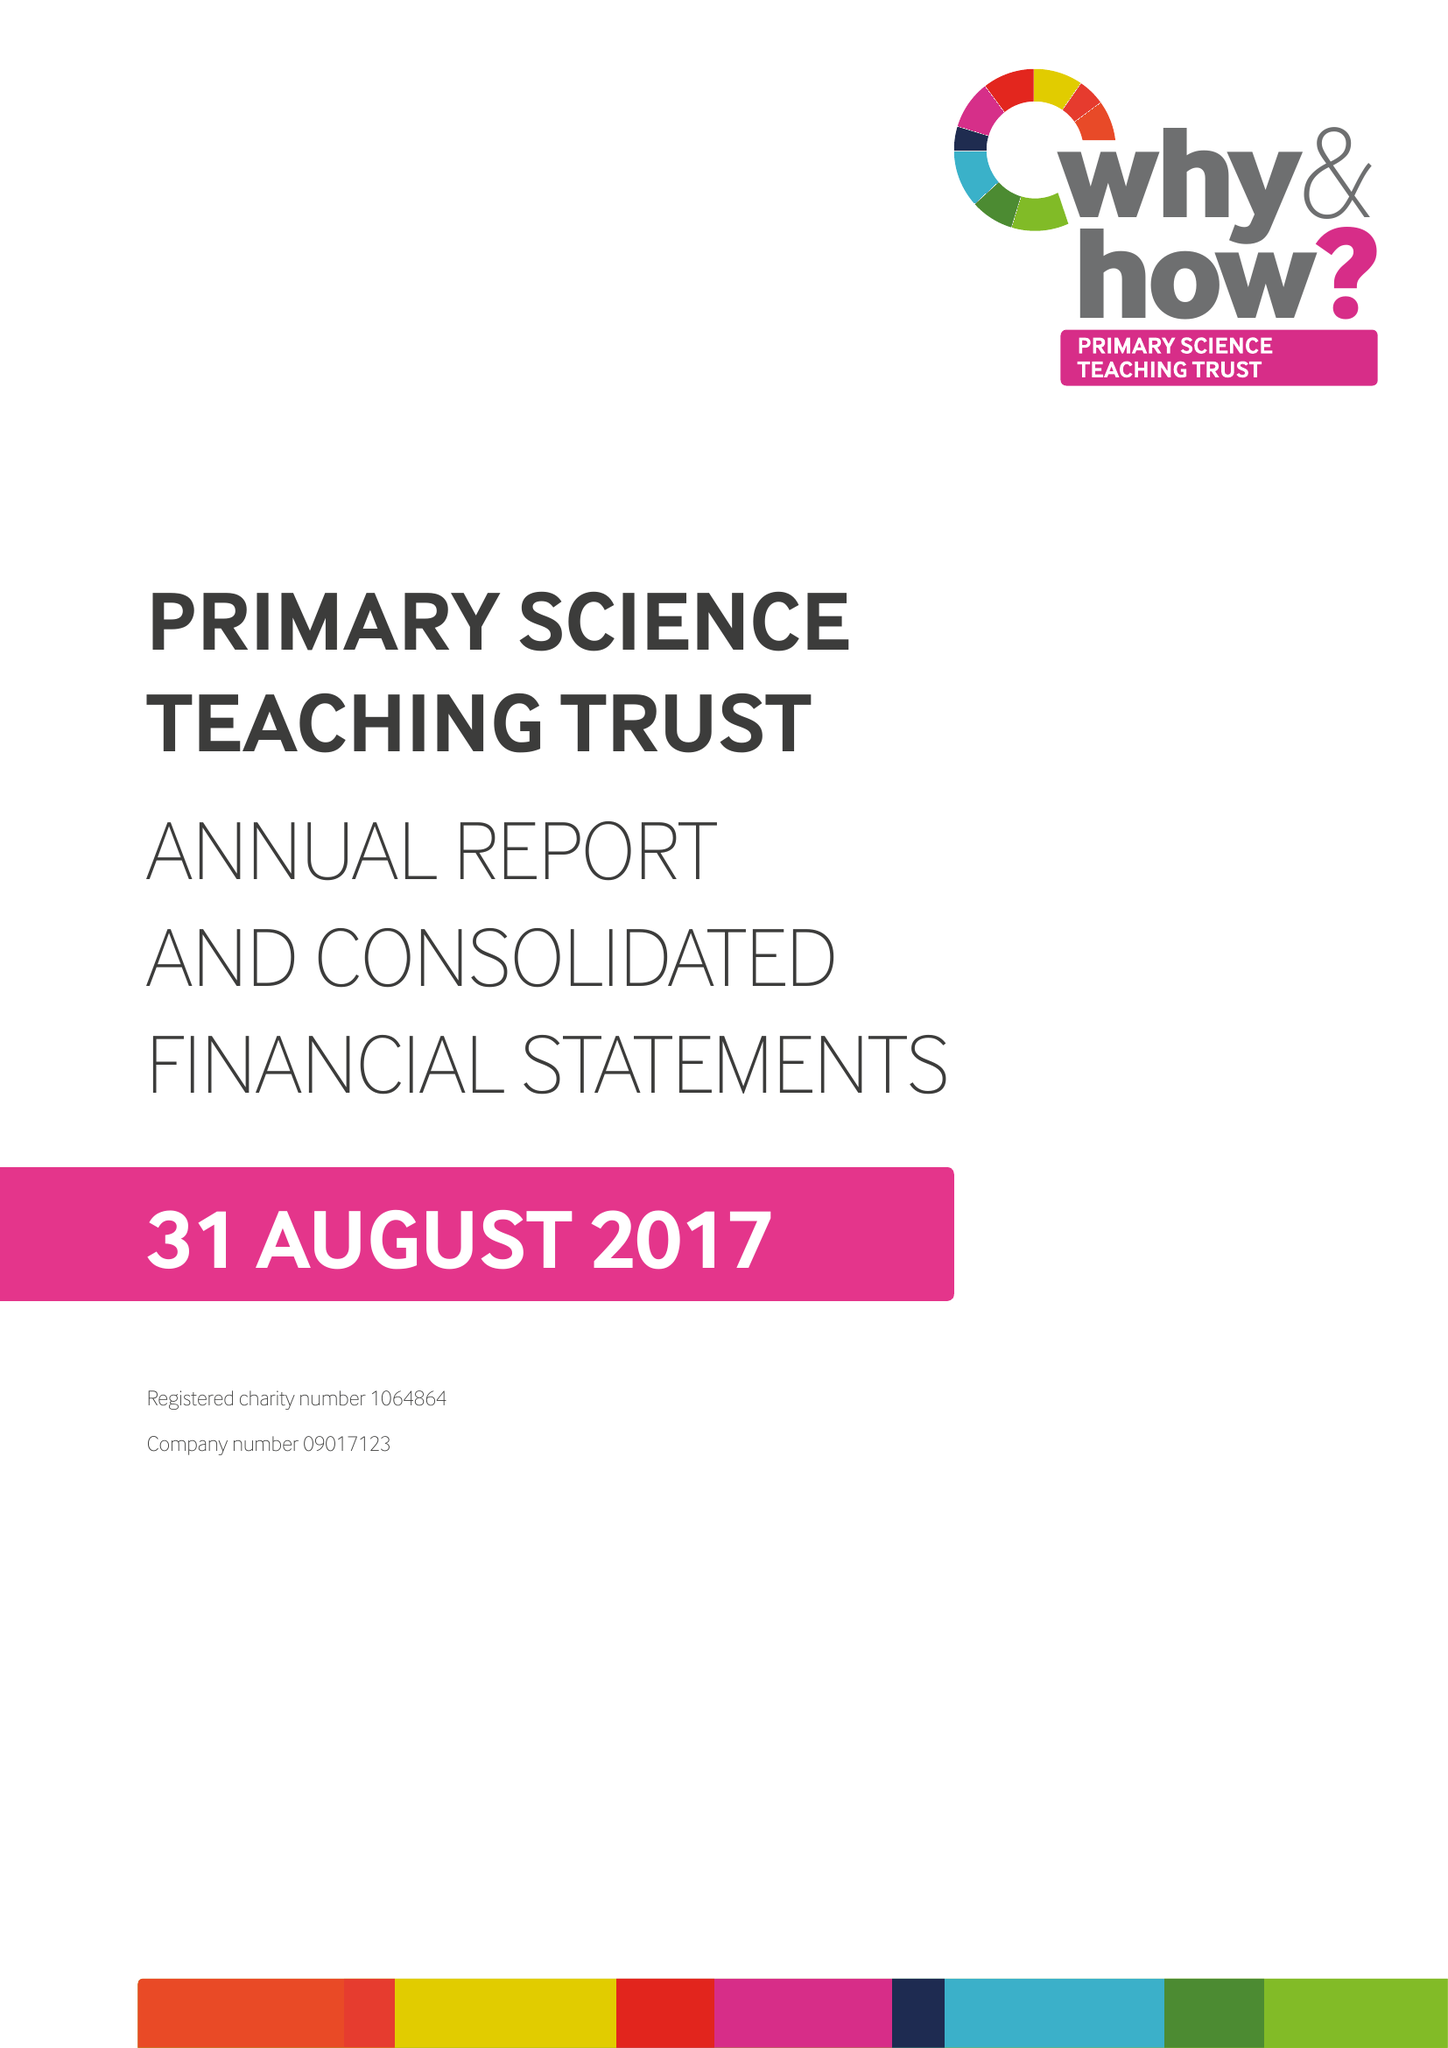What is the value for the spending_annually_in_british_pounds?
Answer the question using a single word or phrase. 1865790.00 